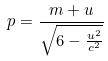<formula> <loc_0><loc_0><loc_500><loc_500>p = \frac { m + u } { \sqrt { 6 - \frac { u ^ { 2 } } { c ^ { 2 } } } }</formula> 